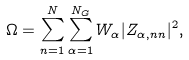<formula> <loc_0><loc_0><loc_500><loc_500>\Omega = \sum _ { n = 1 } ^ { N } \sum _ { \alpha = 1 } ^ { N _ { G } } W _ { \alpha } | Z _ { \alpha , n n } | ^ { 2 } ,</formula> 